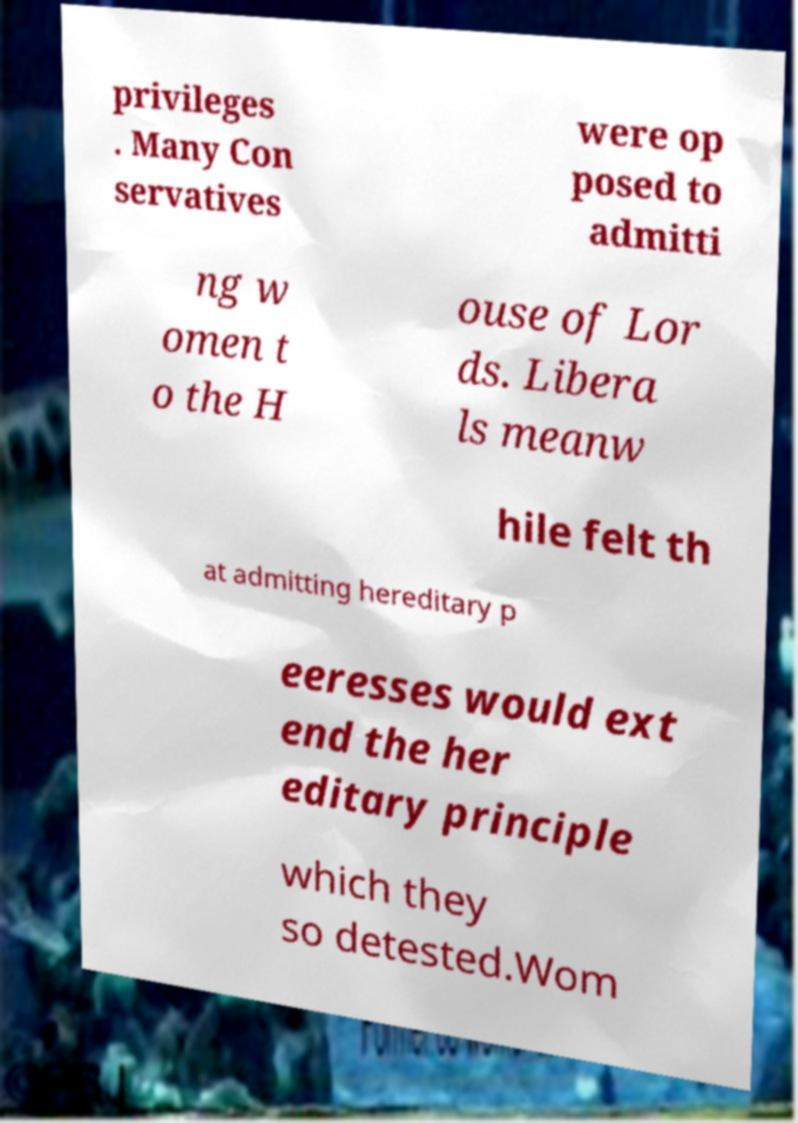Can you accurately transcribe the text from the provided image for me? privileges . Many Con servatives were op posed to admitti ng w omen t o the H ouse of Lor ds. Libera ls meanw hile felt th at admitting hereditary p eeresses would ext end the her editary principle which they so detested.Wom 